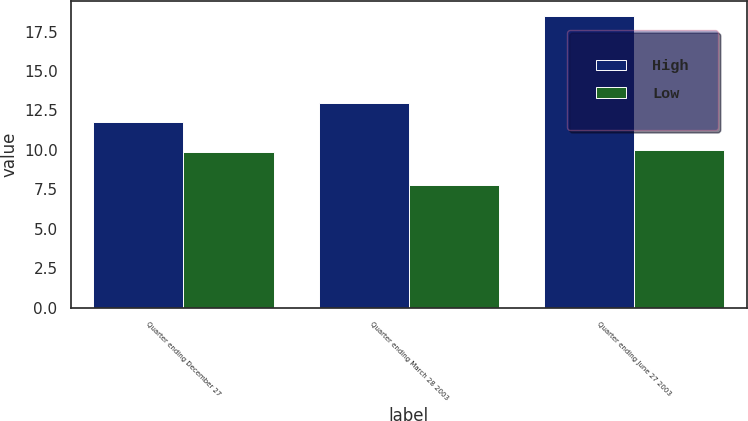Convert chart. <chart><loc_0><loc_0><loc_500><loc_500><stacked_bar_chart><ecel><fcel>Quarter ending December 27<fcel>Quarter ending March 28 2003<fcel>Quarter ending June 27 2003<nl><fcel>High<fcel>11.78<fcel>12.95<fcel>18.49<nl><fcel>Low<fcel>9.86<fcel>7.78<fcel>9.98<nl></chart> 